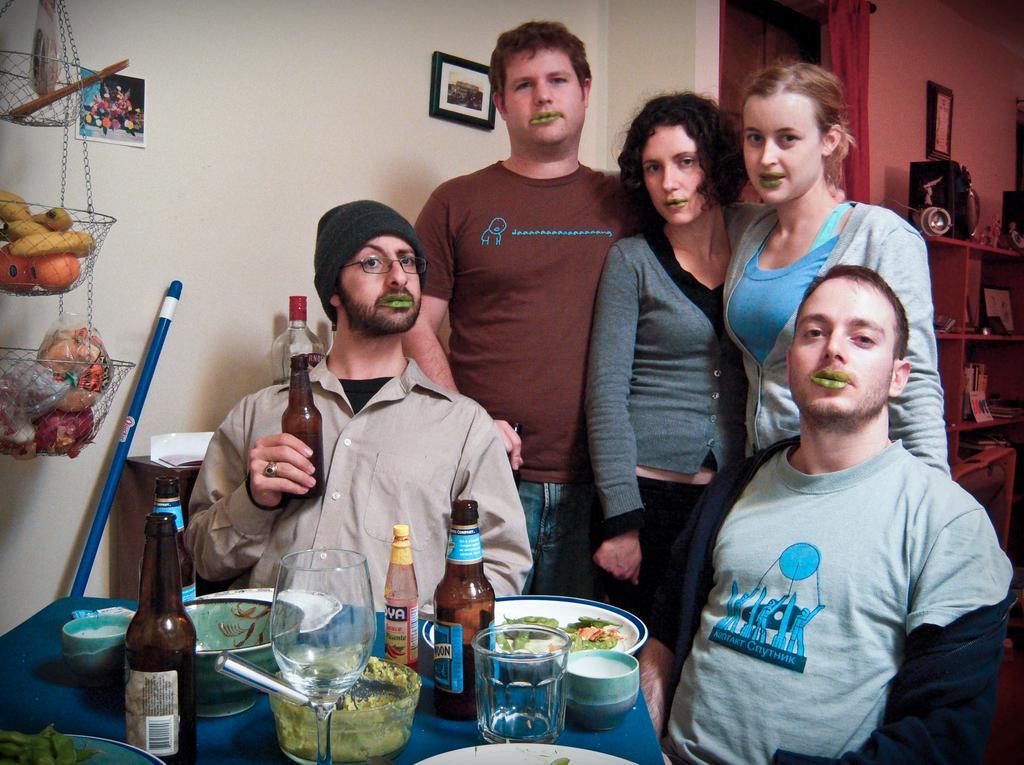Describe this image in one or two sentences. This is the picture of five people among them two are sitting on the chairs and three are standing behind them in front of the table on which some things and behind them there is a shelf in which some things are placed and beside there is a stand in which there are some fruits placed. 